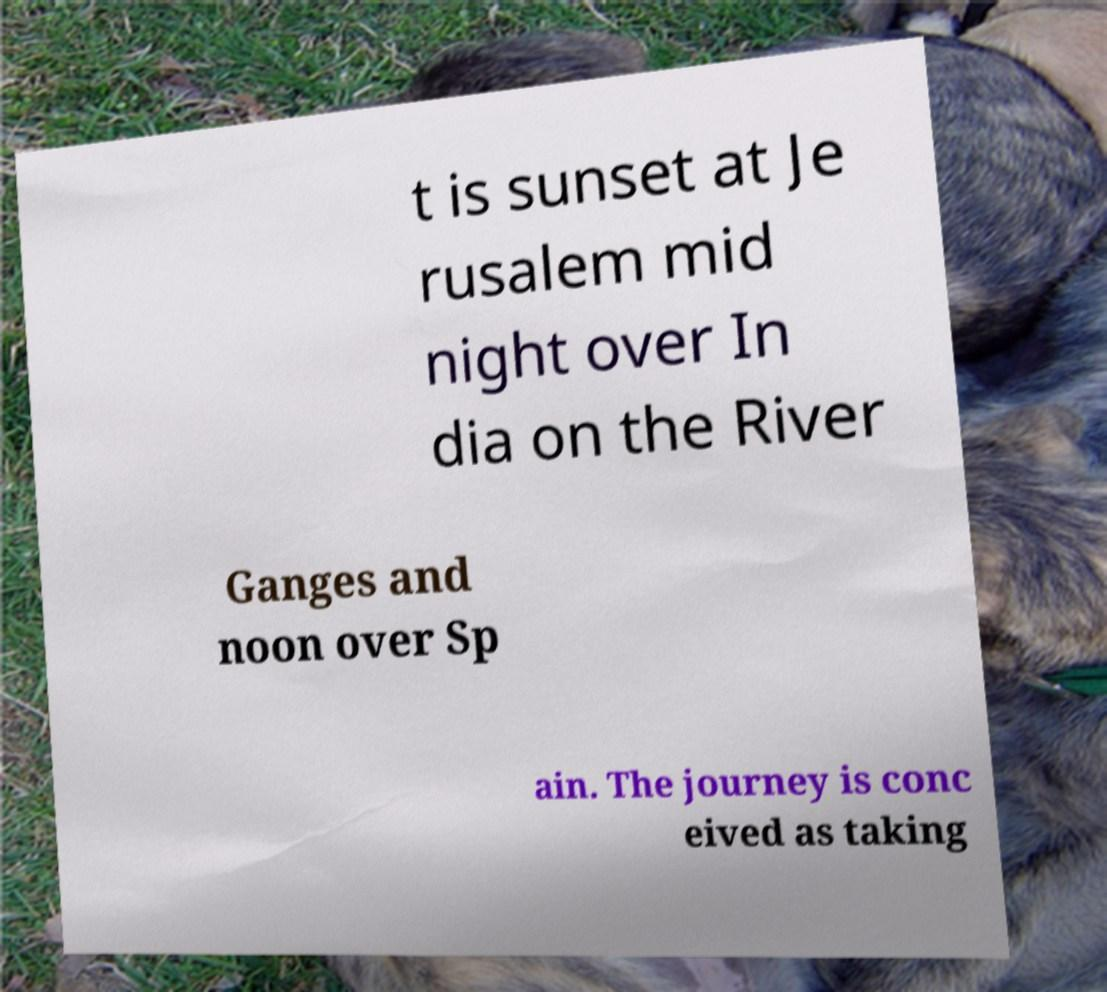Could you extract and type out the text from this image? t is sunset at Je rusalem mid night over In dia on the River Ganges and noon over Sp ain. The journey is conc eived as taking 